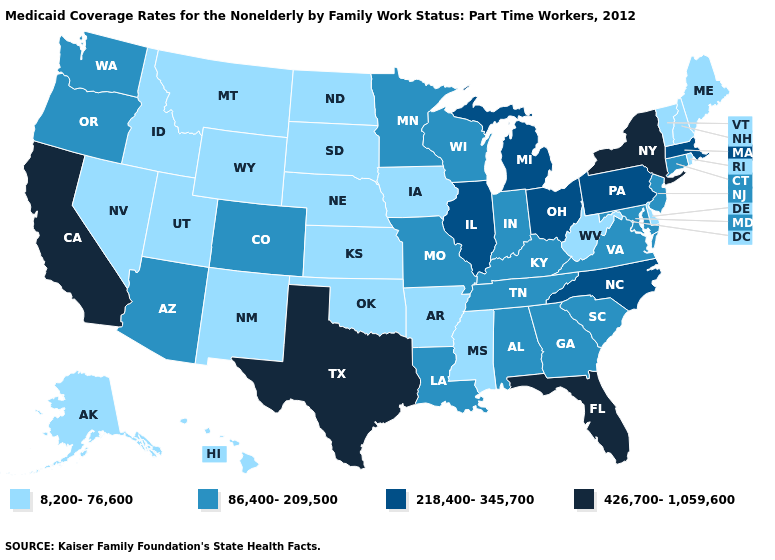Does the map have missing data?
Quick response, please. No. Which states have the lowest value in the West?
Keep it brief. Alaska, Hawaii, Idaho, Montana, Nevada, New Mexico, Utah, Wyoming. Does Kansas have the same value as Nebraska?
Be succinct. Yes. Does Ohio have the highest value in the MidWest?
Give a very brief answer. Yes. Among the states that border South Carolina , which have the lowest value?
Write a very short answer. Georgia. Among the states that border Pennsylvania , which have the highest value?
Write a very short answer. New York. Name the states that have a value in the range 86,400-209,500?
Write a very short answer. Alabama, Arizona, Colorado, Connecticut, Georgia, Indiana, Kentucky, Louisiana, Maryland, Minnesota, Missouri, New Jersey, Oregon, South Carolina, Tennessee, Virginia, Washington, Wisconsin. Does Florida have the highest value in the USA?
Keep it brief. Yes. Does Texas have a lower value than Arizona?
Be succinct. No. What is the value of Texas?
Be succinct. 426,700-1,059,600. Does the map have missing data?
Concise answer only. No. Which states have the highest value in the USA?
Answer briefly. California, Florida, New York, Texas. Among the states that border Mississippi , does Arkansas have the highest value?
Keep it brief. No. Name the states that have a value in the range 86,400-209,500?
Give a very brief answer. Alabama, Arizona, Colorado, Connecticut, Georgia, Indiana, Kentucky, Louisiana, Maryland, Minnesota, Missouri, New Jersey, Oregon, South Carolina, Tennessee, Virginia, Washington, Wisconsin. What is the value of Minnesota?
Quick response, please. 86,400-209,500. 